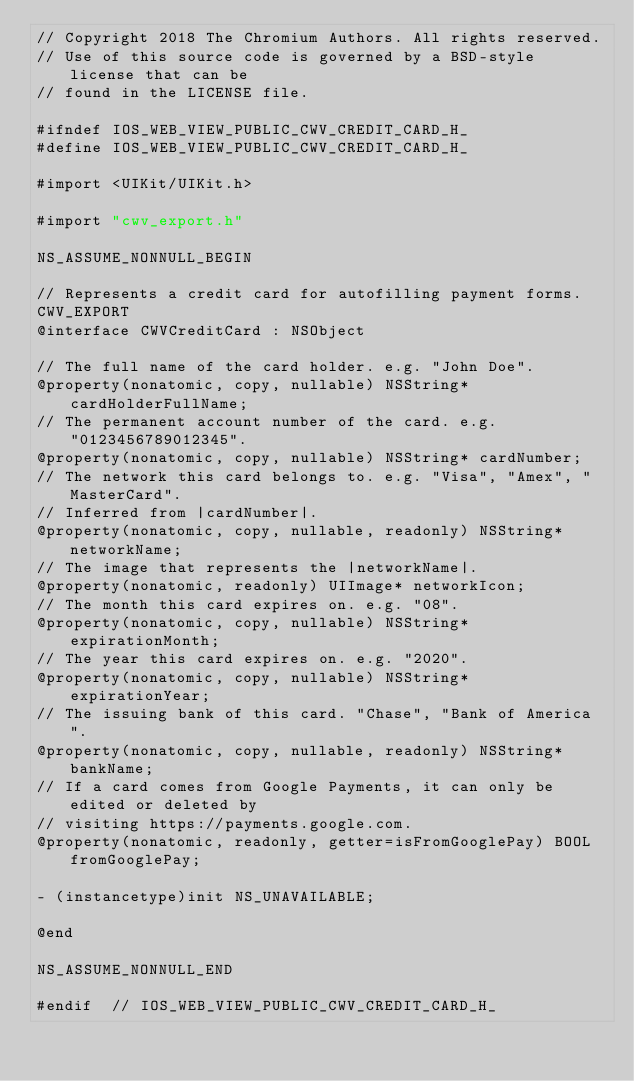<code> <loc_0><loc_0><loc_500><loc_500><_C_>// Copyright 2018 The Chromium Authors. All rights reserved.
// Use of this source code is governed by a BSD-style license that can be
// found in the LICENSE file.

#ifndef IOS_WEB_VIEW_PUBLIC_CWV_CREDIT_CARD_H_
#define IOS_WEB_VIEW_PUBLIC_CWV_CREDIT_CARD_H_

#import <UIKit/UIKit.h>

#import "cwv_export.h"

NS_ASSUME_NONNULL_BEGIN

// Represents a credit card for autofilling payment forms.
CWV_EXPORT
@interface CWVCreditCard : NSObject

// The full name of the card holder. e.g. "John Doe".
@property(nonatomic, copy, nullable) NSString* cardHolderFullName;
// The permanent account number of the card. e.g. "0123456789012345".
@property(nonatomic, copy, nullable) NSString* cardNumber;
// The network this card belongs to. e.g. "Visa", "Amex", "MasterCard".
// Inferred from |cardNumber|.
@property(nonatomic, copy, nullable, readonly) NSString* networkName;
// The image that represents the |networkName|.
@property(nonatomic, readonly) UIImage* networkIcon;
// The month this card expires on. e.g. "08".
@property(nonatomic, copy, nullable) NSString* expirationMonth;
// The year this card expires on. e.g. "2020".
@property(nonatomic, copy, nullable) NSString* expirationYear;
// The issuing bank of this card. "Chase", "Bank of America".
@property(nonatomic, copy, nullable, readonly) NSString* bankName;
// If a card comes from Google Payments, it can only be edited or deleted by
// visiting https://payments.google.com.
@property(nonatomic, readonly, getter=isFromGooglePay) BOOL fromGooglePay;

- (instancetype)init NS_UNAVAILABLE;

@end

NS_ASSUME_NONNULL_END

#endif  // IOS_WEB_VIEW_PUBLIC_CWV_CREDIT_CARD_H_
</code> 